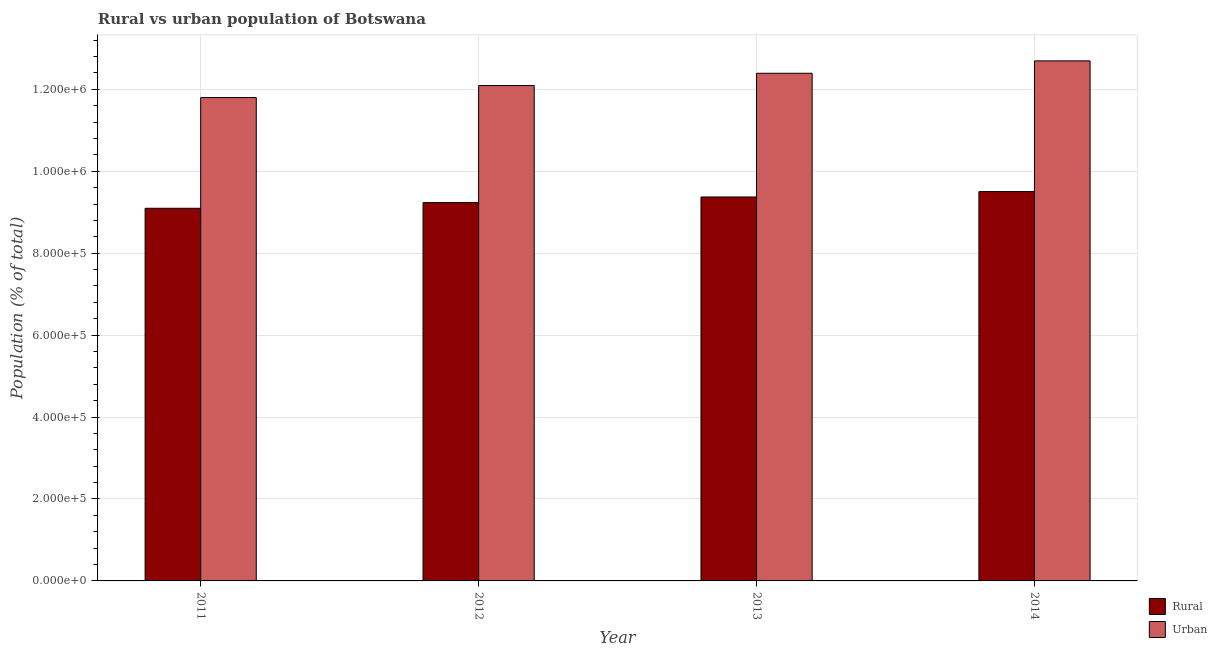Are the number of bars per tick equal to the number of legend labels?
Your answer should be very brief. Yes. Are the number of bars on each tick of the X-axis equal?
Offer a very short reply. Yes. How many bars are there on the 2nd tick from the left?
Make the answer very short. 2. How many bars are there on the 4th tick from the right?
Ensure brevity in your answer.  2. In how many cases, is the number of bars for a given year not equal to the number of legend labels?
Provide a succinct answer. 0. What is the urban population density in 2011?
Provide a short and direct response. 1.18e+06. Across all years, what is the maximum urban population density?
Your response must be concise. 1.27e+06. Across all years, what is the minimum rural population density?
Your answer should be compact. 9.10e+05. In which year was the rural population density maximum?
Keep it short and to the point. 2014. What is the total rural population density in the graph?
Your response must be concise. 3.72e+06. What is the difference between the rural population density in 2012 and that in 2013?
Keep it short and to the point. -1.37e+04. What is the difference between the urban population density in 2012 and the rural population density in 2011?
Offer a terse response. 2.93e+04. What is the average rural population density per year?
Keep it short and to the point. 9.30e+05. In how many years, is the urban population density greater than 400000 %?
Your answer should be compact. 4. What is the ratio of the urban population density in 2011 to that in 2013?
Give a very brief answer. 0.95. Is the urban population density in 2012 less than that in 2013?
Make the answer very short. Yes. Is the difference between the urban population density in 2012 and 2013 greater than the difference between the rural population density in 2012 and 2013?
Provide a succinct answer. No. What is the difference between the highest and the second highest urban population density?
Your response must be concise. 3.03e+04. What is the difference between the highest and the lowest rural population density?
Give a very brief answer. 4.07e+04. Is the sum of the urban population density in 2011 and 2013 greater than the maximum rural population density across all years?
Offer a terse response. Yes. What does the 2nd bar from the left in 2011 represents?
Your answer should be very brief. Urban. What does the 1st bar from the right in 2011 represents?
Give a very brief answer. Urban. How many bars are there?
Provide a short and direct response. 8. Are the values on the major ticks of Y-axis written in scientific E-notation?
Give a very brief answer. Yes. Does the graph contain any zero values?
Give a very brief answer. No. Does the graph contain grids?
Your answer should be very brief. Yes. How many legend labels are there?
Your answer should be compact. 2. How are the legend labels stacked?
Make the answer very short. Vertical. What is the title of the graph?
Offer a very short reply. Rural vs urban population of Botswana. What is the label or title of the X-axis?
Make the answer very short. Year. What is the label or title of the Y-axis?
Your answer should be very brief. Population (% of total). What is the Population (% of total) of Rural in 2011?
Your answer should be compact. 9.10e+05. What is the Population (% of total) of Urban in 2011?
Ensure brevity in your answer.  1.18e+06. What is the Population (% of total) in Rural in 2012?
Offer a very short reply. 9.24e+05. What is the Population (% of total) in Urban in 2012?
Your answer should be very brief. 1.21e+06. What is the Population (% of total) of Rural in 2013?
Give a very brief answer. 9.37e+05. What is the Population (% of total) of Urban in 2013?
Give a very brief answer. 1.24e+06. What is the Population (% of total) in Rural in 2014?
Your answer should be compact. 9.50e+05. What is the Population (% of total) in Urban in 2014?
Your response must be concise. 1.27e+06. Across all years, what is the maximum Population (% of total) in Rural?
Keep it short and to the point. 9.50e+05. Across all years, what is the maximum Population (% of total) of Urban?
Offer a very short reply. 1.27e+06. Across all years, what is the minimum Population (% of total) in Rural?
Offer a very short reply. 9.10e+05. Across all years, what is the minimum Population (% of total) in Urban?
Provide a succinct answer. 1.18e+06. What is the total Population (% of total) of Rural in the graph?
Your response must be concise. 3.72e+06. What is the total Population (% of total) in Urban in the graph?
Your response must be concise. 4.90e+06. What is the difference between the Population (% of total) of Rural in 2011 and that in 2012?
Keep it short and to the point. -1.38e+04. What is the difference between the Population (% of total) in Urban in 2011 and that in 2012?
Ensure brevity in your answer.  -2.93e+04. What is the difference between the Population (% of total) in Rural in 2011 and that in 2013?
Your response must be concise. -2.75e+04. What is the difference between the Population (% of total) in Urban in 2011 and that in 2013?
Offer a very short reply. -5.93e+04. What is the difference between the Population (% of total) of Rural in 2011 and that in 2014?
Your answer should be compact. -4.07e+04. What is the difference between the Population (% of total) in Urban in 2011 and that in 2014?
Offer a terse response. -8.95e+04. What is the difference between the Population (% of total) of Rural in 2012 and that in 2013?
Provide a succinct answer. -1.37e+04. What is the difference between the Population (% of total) of Urban in 2012 and that in 2013?
Your answer should be compact. -3.00e+04. What is the difference between the Population (% of total) in Rural in 2012 and that in 2014?
Offer a terse response. -2.69e+04. What is the difference between the Population (% of total) of Urban in 2012 and that in 2014?
Your answer should be very brief. -6.02e+04. What is the difference between the Population (% of total) in Rural in 2013 and that in 2014?
Your response must be concise. -1.32e+04. What is the difference between the Population (% of total) of Urban in 2013 and that in 2014?
Make the answer very short. -3.03e+04. What is the difference between the Population (% of total) in Rural in 2011 and the Population (% of total) in Urban in 2012?
Offer a very short reply. -3.00e+05. What is the difference between the Population (% of total) in Rural in 2011 and the Population (% of total) in Urban in 2013?
Keep it short and to the point. -3.30e+05. What is the difference between the Population (% of total) of Rural in 2011 and the Population (% of total) of Urban in 2014?
Your response must be concise. -3.60e+05. What is the difference between the Population (% of total) of Rural in 2012 and the Population (% of total) of Urban in 2013?
Provide a succinct answer. -3.16e+05. What is the difference between the Population (% of total) of Rural in 2012 and the Population (% of total) of Urban in 2014?
Your response must be concise. -3.46e+05. What is the difference between the Population (% of total) in Rural in 2013 and the Population (% of total) in Urban in 2014?
Offer a terse response. -3.32e+05. What is the average Population (% of total) of Rural per year?
Give a very brief answer. 9.30e+05. What is the average Population (% of total) of Urban per year?
Ensure brevity in your answer.  1.22e+06. In the year 2011, what is the difference between the Population (% of total) in Rural and Population (% of total) in Urban?
Your answer should be very brief. -2.70e+05. In the year 2012, what is the difference between the Population (% of total) of Rural and Population (% of total) of Urban?
Provide a short and direct response. -2.86e+05. In the year 2013, what is the difference between the Population (% of total) of Rural and Population (% of total) of Urban?
Your answer should be very brief. -3.02e+05. In the year 2014, what is the difference between the Population (% of total) in Rural and Population (% of total) in Urban?
Your answer should be compact. -3.19e+05. What is the ratio of the Population (% of total) of Urban in 2011 to that in 2012?
Provide a succinct answer. 0.98. What is the ratio of the Population (% of total) in Rural in 2011 to that in 2013?
Your answer should be very brief. 0.97. What is the ratio of the Population (% of total) in Urban in 2011 to that in 2013?
Your answer should be compact. 0.95. What is the ratio of the Population (% of total) of Rural in 2011 to that in 2014?
Your answer should be very brief. 0.96. What is the ratio of the Population (% of total) of Urban in 2011 to that in 2014?
Provide a short and direct response. 0.93. What is the ratio of the Population (% of total) of Rural in 2012 to that in 2013?
Provide a succinct answer. 0.99. What is the ratio of the Population (% of total) of Urban in 2012 to that in 2013?
Make the answer very short. 0.98. What is the ratio of the Population (% of total) of Rural in 2012 to that in 2014?
Offer a very short reply. 0.97. What is the ratio of the Population (% of total) in Urban in 2012 to that in 2014?
Keep it short and to the point. 0.95. What is the ratio of the Population (% of total) of Rural in 2013 to that in 2014?
Give a very brief answer. 0.99. What is the ratio of the Population (% of total) in Urban in 2013 to that in 2014?
Your response must be concise. 0.98. What is the difference between the highest and the second highest Population (% of total) in Rural?
Offer a terse response. 1.32e+04. What is the difference between the highest and the second highest Population (% of total) of Urban?
Provide a short and direct response. 3.03e+04. What is the difference between the highest and the lowest Population (% of total) of Rural?
Your answer should be compact. 4.07e+04. What is the difference between the highest and the lowest Population (% of total) in Urban?
Offer a very short reply. 8.95e+04. 